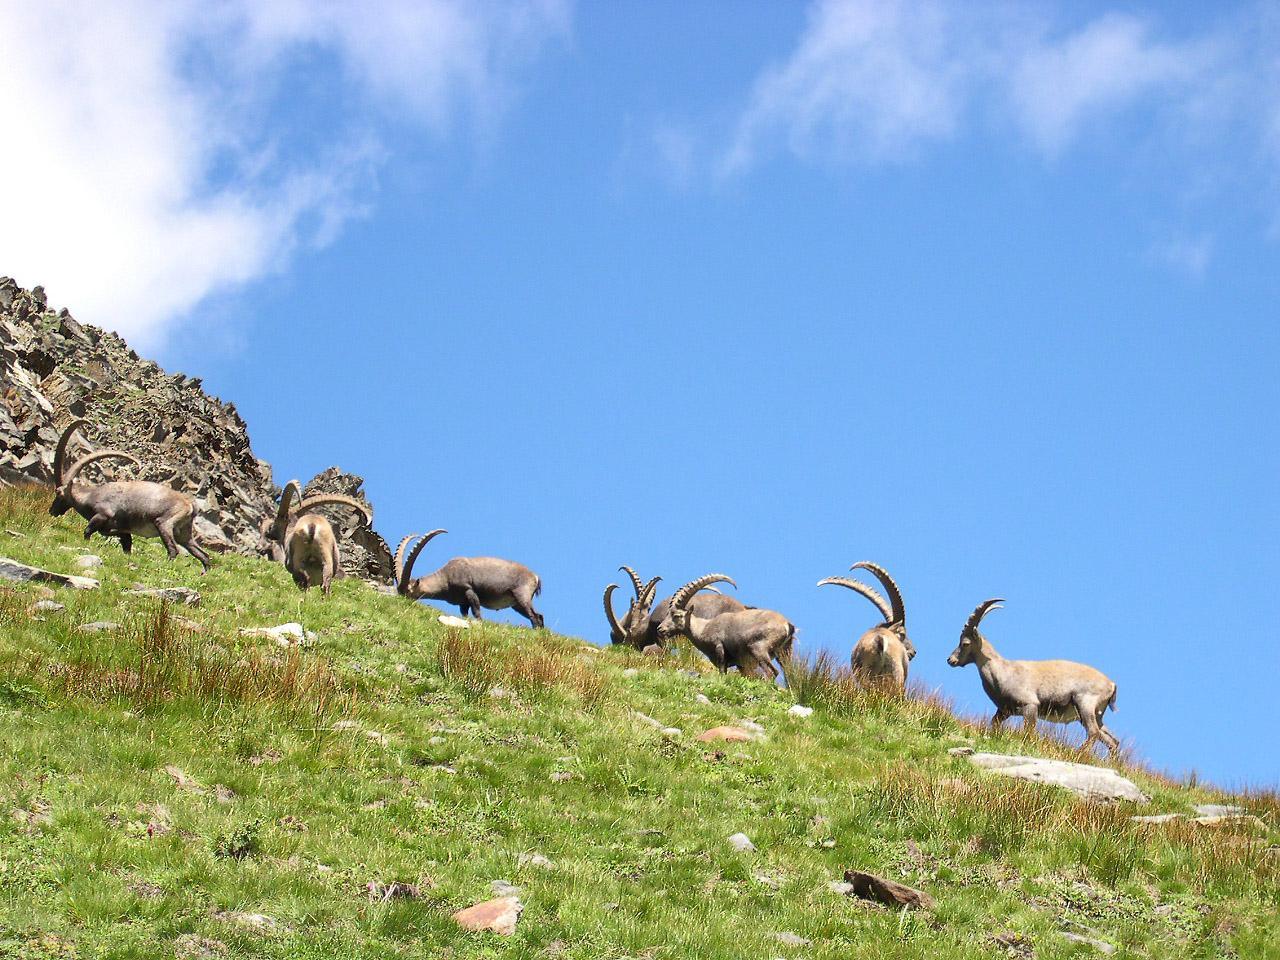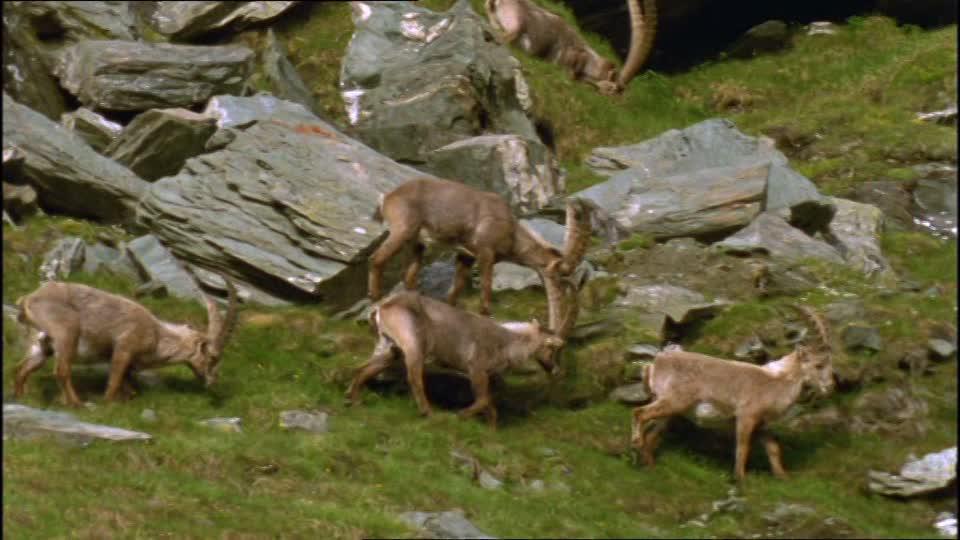The first image is the image on the left, the second image is the image on the right. Examine the images to the left and right. Is the description "The roof of a structure is visible in an image containing a horned goat." accurate? Answer yes or no. No. The first image is the image on the left, the second image is the image on the right. Analyze the images presented: Is the assertion "the animals in the image on the left are on grass" valid? Answer yes or no. Yes. 